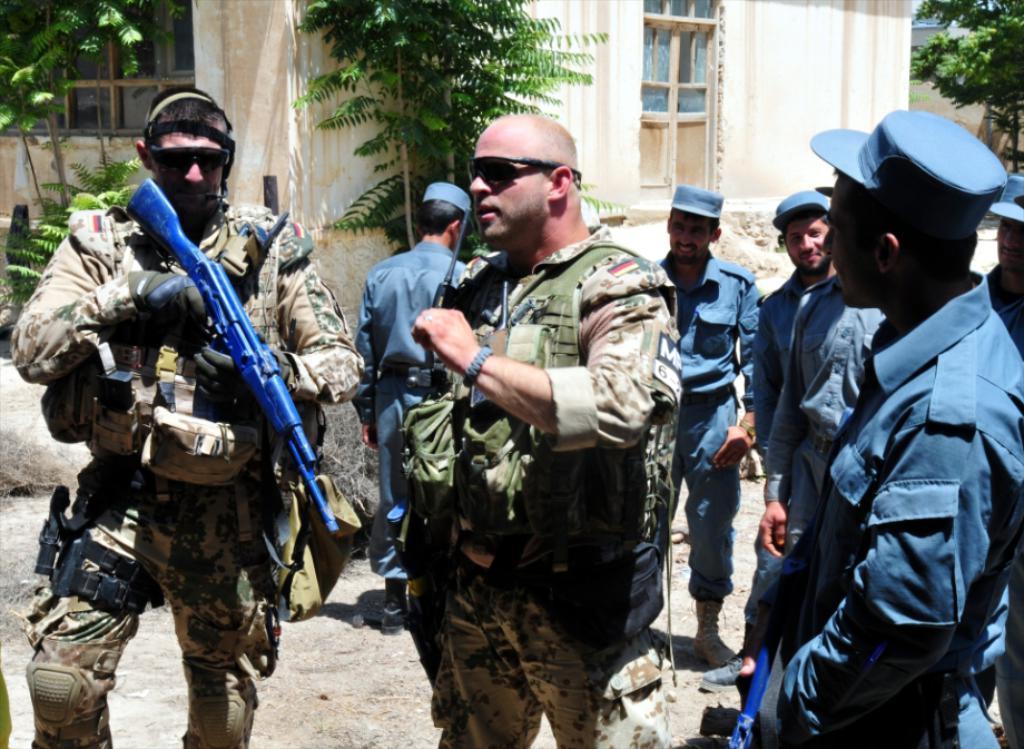Please provide a concise description of this image. In this picture there are group of persons standing. On the left side there is a man standing and holding a gun. In the background there are trees and there are buildings. 